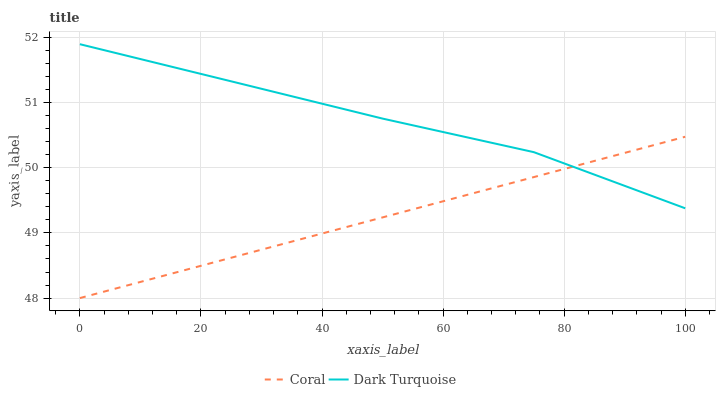Does Coral have the minimum area under the curve?
Answer yes or no. Yes. Does Dark Turquoise have the maximum area under the curve?
Answer yes or no. Yes. Does Coral have the maximum area under the curve?
Answer yes or no. No. Is Coral the smoothest?
Answer yes or no. Yes. Is Dark Turquoise the roughest?
Answer yes or no. Yes. Is Coral the roughest?
Answer yes or no. No. Does Coral have the lowest value?
Answer yes or no. Yes. Does Dark Turquoise have the highest value?
Answer yes or no. Yes. Does Coral have the highest value?
Answer yes or no. No. Does Dark Turquoise intersect Coral?
Answer yes or no. Yes. Is Dark Turquoise less than Coral?
Answer yes or no. No. Is Dark Turquoise greater than Coral?
Answer yes or no. No. 